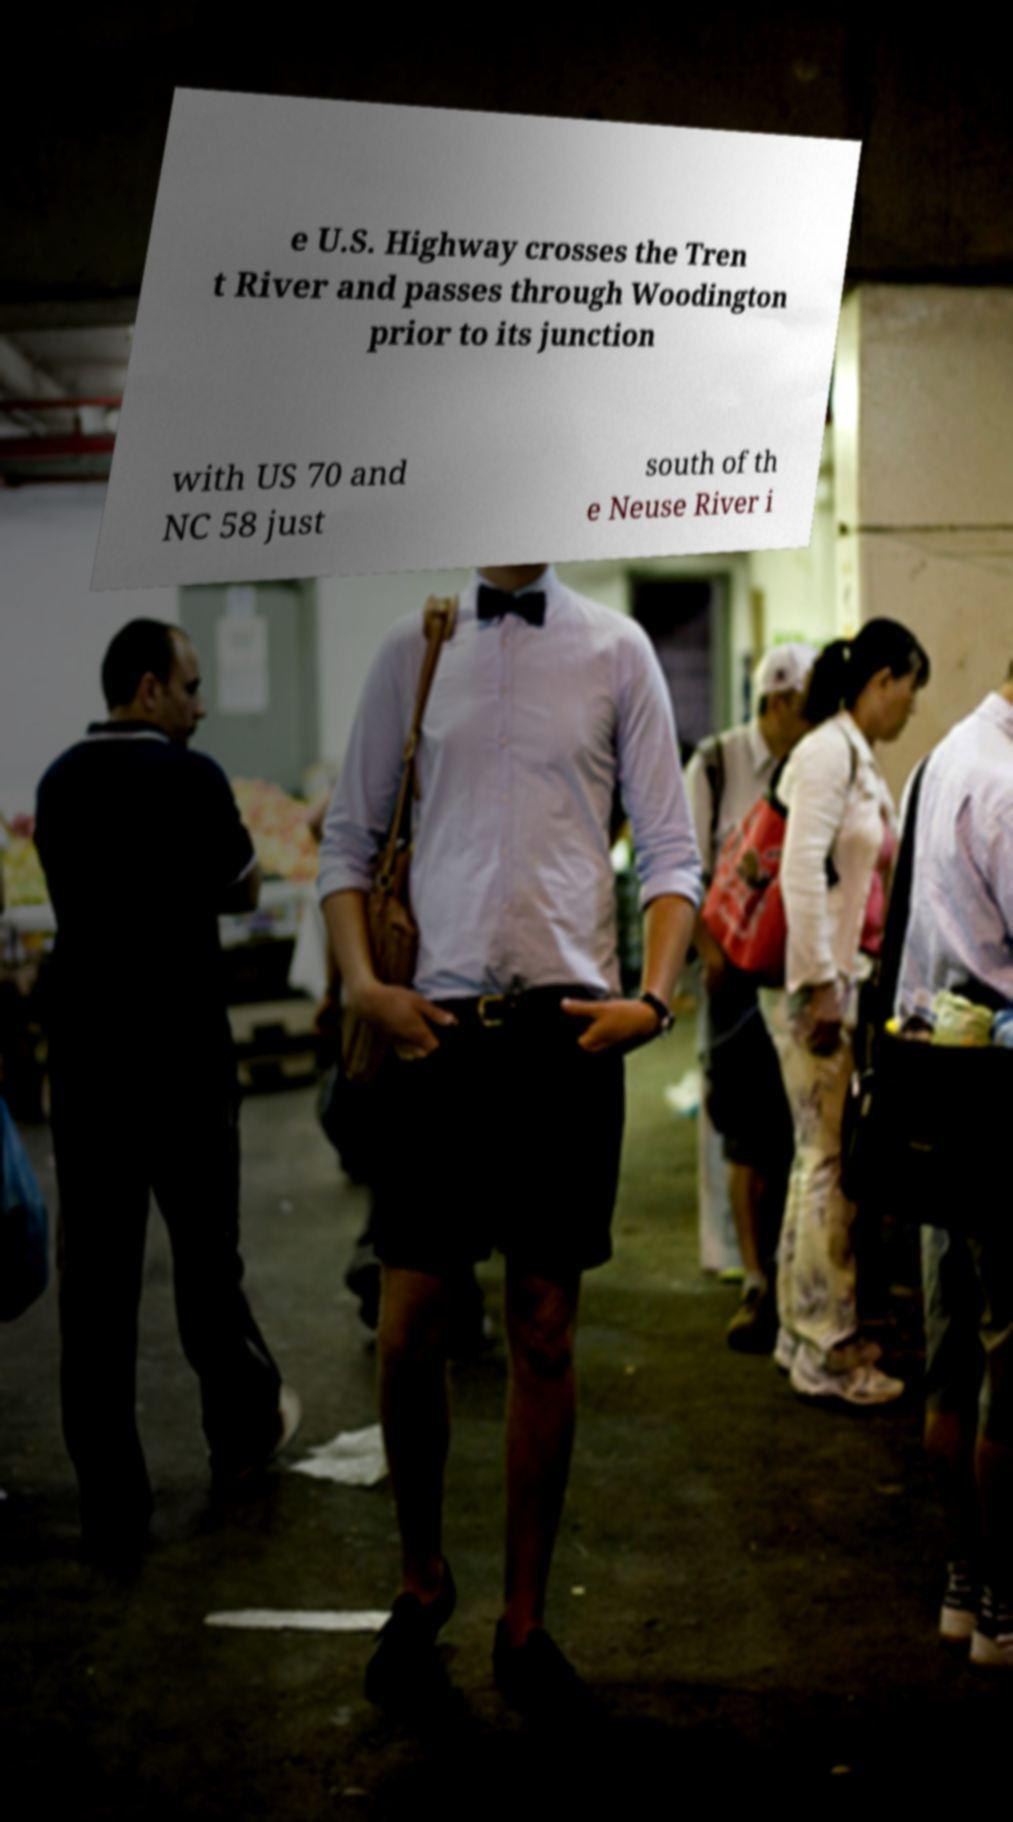There's text embedded in this image that I need extracted. Can you transcribe it verbatim? e U.S. Highway crosses the Tren t River and passes through Woodington prior to its junction with US 70 and NC 58 just south of th e Neuse River i 